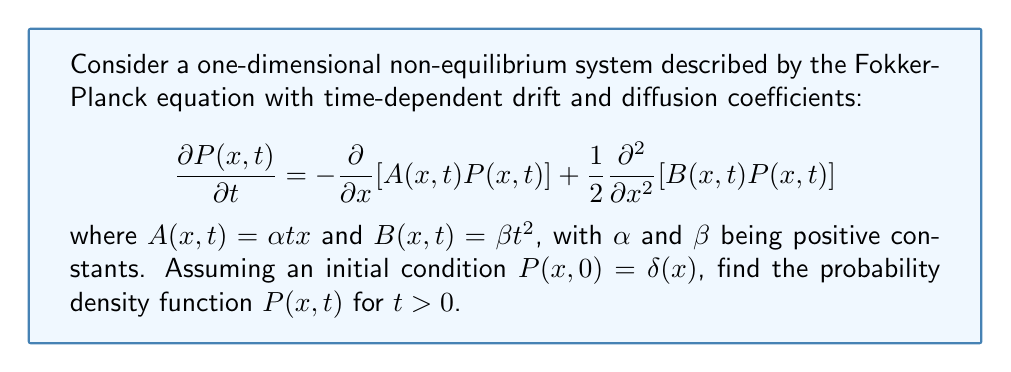Can you answer this question? 1) First, we recognize that this is a linear Fokker-Planck equation with time-dependent coefficients. The solution will be a Gaussian distribution with time-dependent mean and variance.

2) For a Gaussian distribution, we can write:

   $$P(x,t) = \frac{1}{\sqrt{2\pi\sigma^2(t)}}\exp\left(-\frac{(x-\mu(t))^2}{2\sigma^2(t)}\right)$$

   where $\mu(t)$ is the mean and $\sigma^2(t)$ is the variance.

3) To find $\mu(t)$ and $\sigma^2(t)$, we need to solve the following ordinary differential equations:

   $$\frac{d\mu}{dt} = A(\mu,t) = \alpha t \mu$$
   $$\frac{d\sigma^2}{dt} = B(\mu,t) = \beta t^2$$

4) For the mean:
   $$\frac{d\mu}{dt} = \alpha t \mu$$
   $$\frac{d\mu}{\mu} = \alpha t dt$$
   $$\ln\mu = \frac{\alpha t^2}{2} + C$$
   $$\mu(t) = C_1 \exp(\frac{\alpha t^2}{2})$$

   Given $P(x,0) = \delta(x)$, we know $\mu(0) = 0$, so $C_1 = 0$.
   Therefore, $\mu(t) = 0$ for all $t$.

5) For the variance:
   $$\frac{d\sigma^2}{dt} = \beta t^2$$
   $$\sigma^2(t) = \frac{\beta t^3}{3} + C_2$$

   Given $P(x,0) = \delta(x)$, we know $\sigma^2(0) = 0$, so $C_2 = 0$.

6) Substituting these results into the Gaussian distribution formula:

   $$P(x,t) = \sqrt{\frac{3}{2\pi\beta t^3}}\exp\left(-\frac{3x^2}{2\beta t^3}\right)$$
Answer: $$P(x,t) = \sqrt{\frac{3}{2\pi\beta t^3}}\exp\left(-\frac{3x^2}{2\beta t^3}\right)$$ 